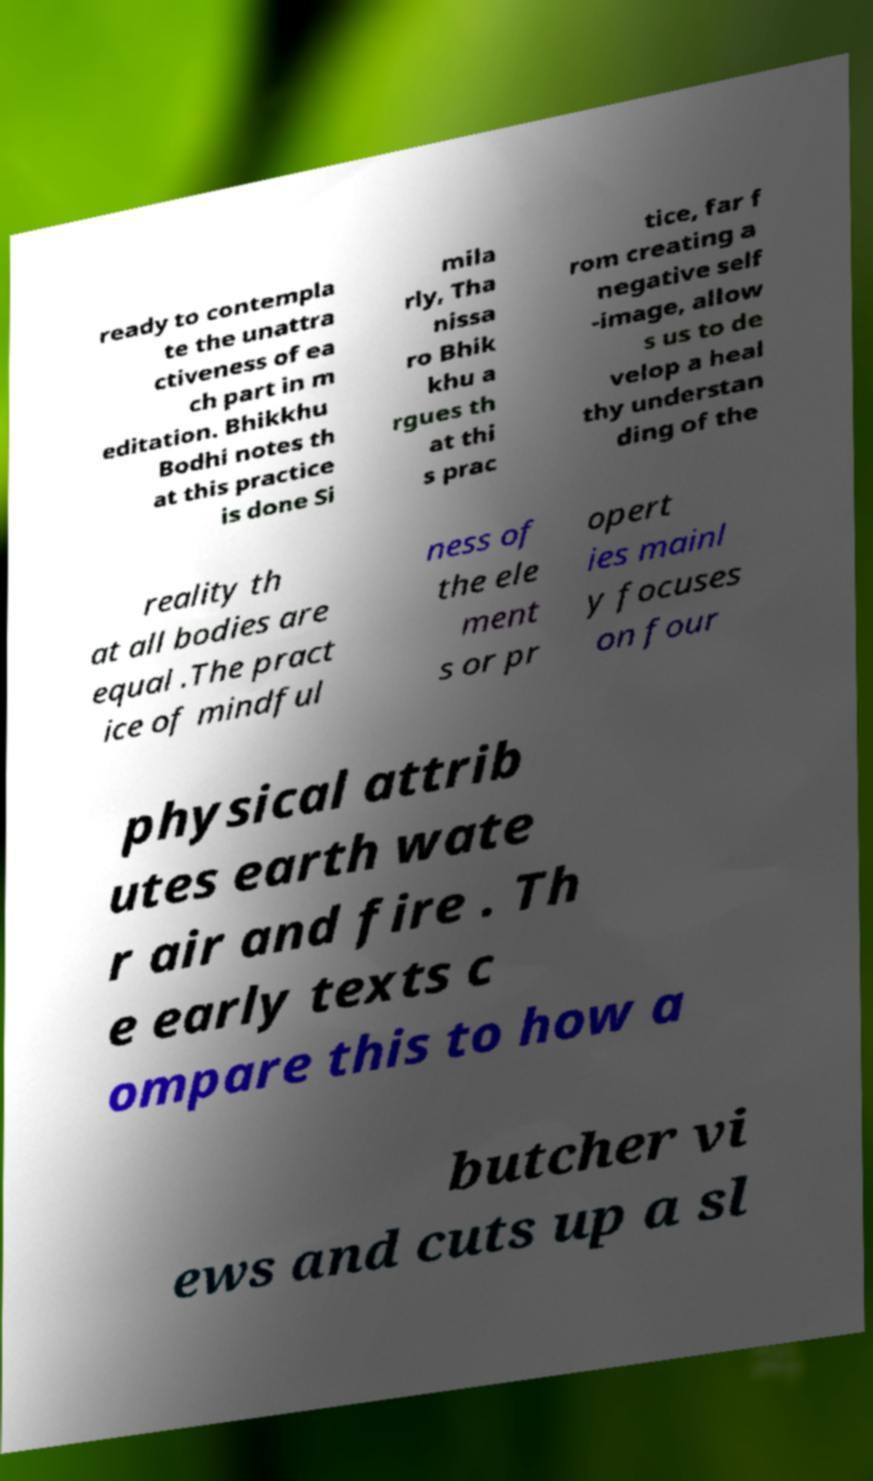Please read and relay the text visible in this image. What does it say? ready to contempla te the unattra ctiveness of ea ch part in m editation. Bhikkhu Bodhi notes th at this practice is done Si mila rly, Tha nissa ro Bhik khu a rgues th at thi s prac tice, far f rom creating a negative self -image, allow s us to de velop a heal thy understan ding of the reality th at all bodies are equal .The pract ice of mindful ness of the ele ment s or pr opert ies mainl y focuses on four physical attrib utes earth wate r air and fire . Th e early texts c ompare this to how a butcher vi ews and cuts up a sl 